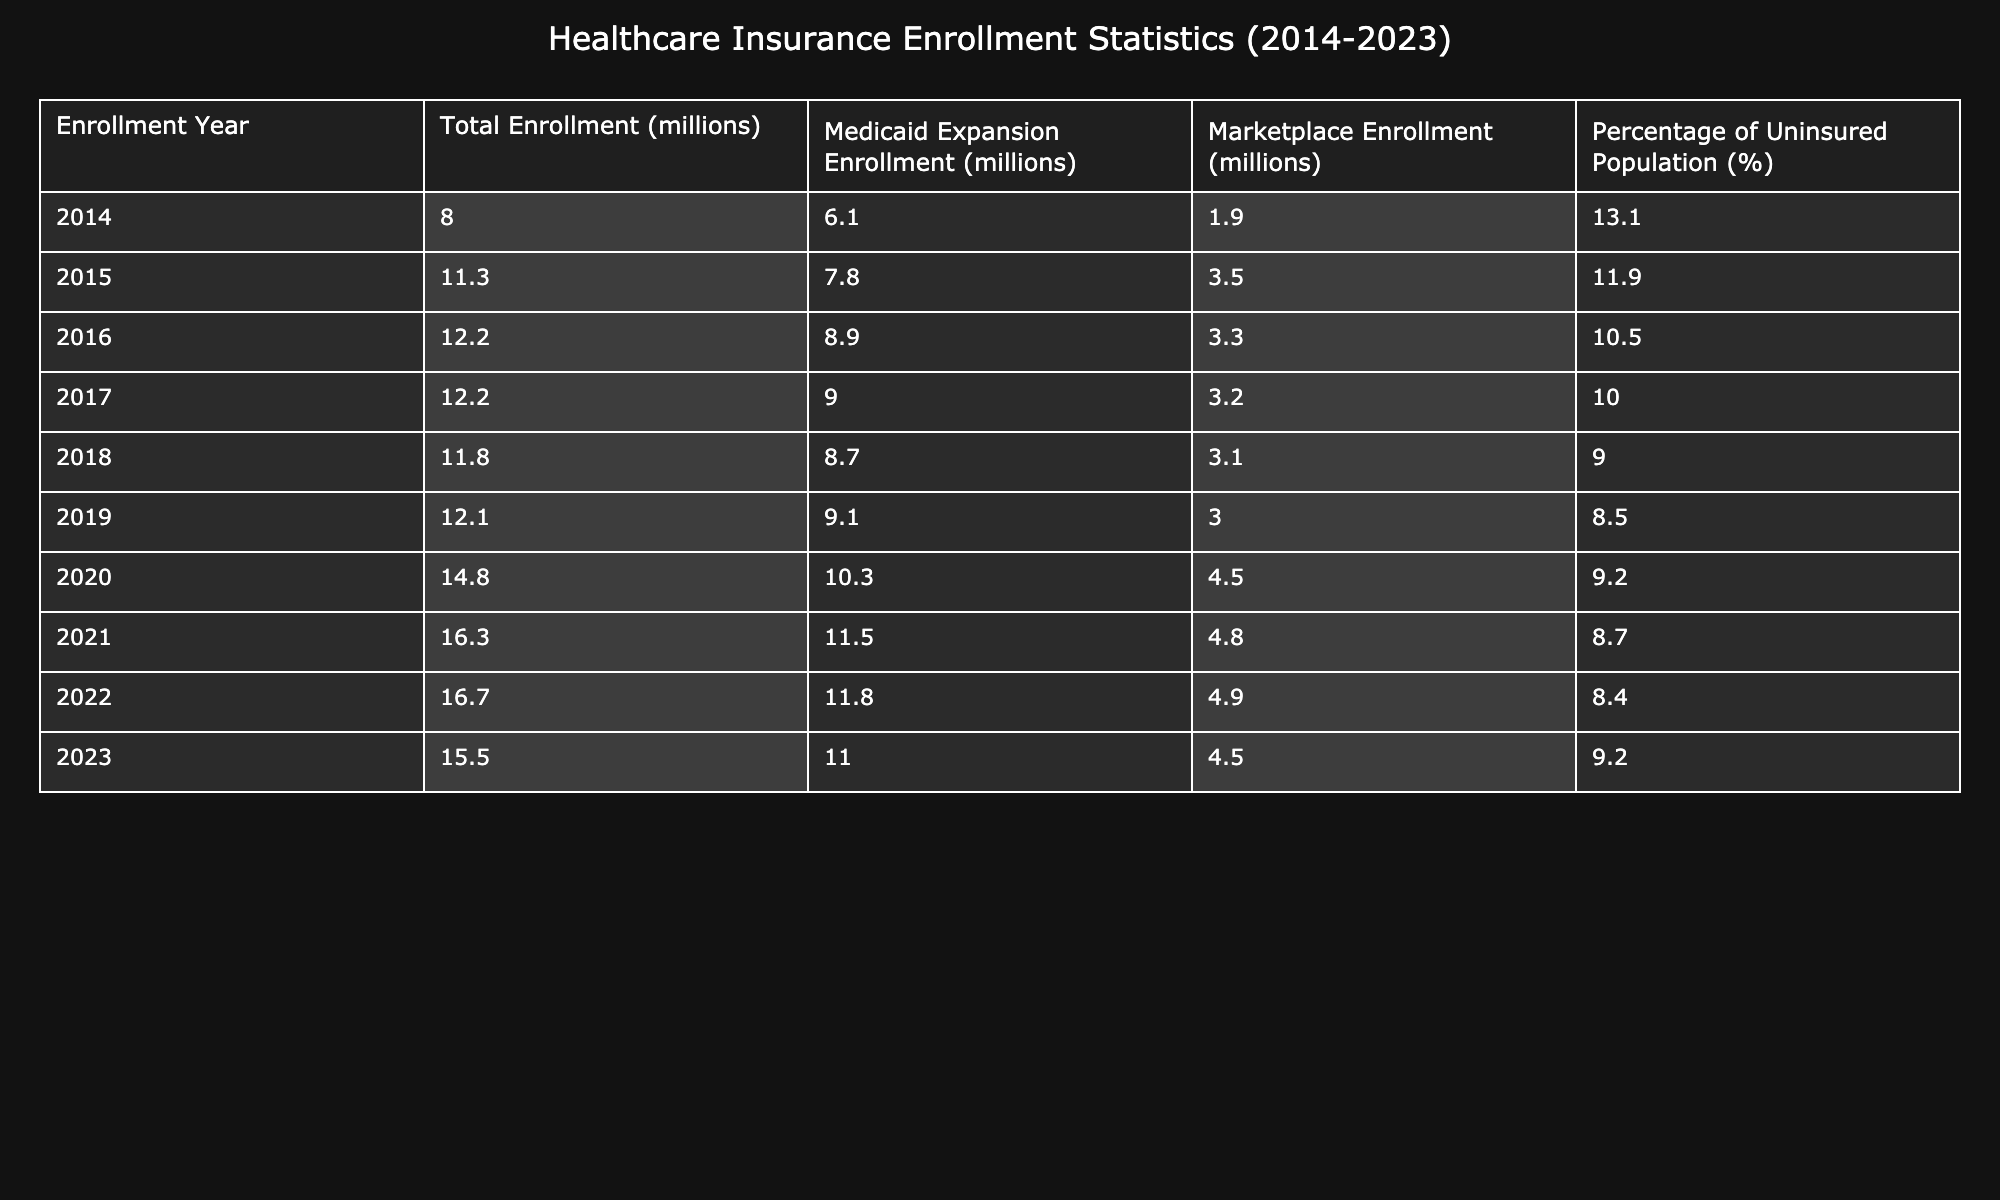What's the total enrollment in 2020? For the year 2020, the "Total Enrollment" value is directly referenced in the table, which shows it as 14.8 million.
Answer: 14.8 million What percentage of the uninsured population was there in 2015? By checking the "Percentage of Uninsured Population" column for the year 2015, the value is noted as 11.9%.
Answer: 11.9% How many millions enrolled in the Medicaid expansion in 2018? The "Medicaid Expansion Enrollment" for the year 2018 is clearly stated in the table as 8.7 million.
Answer: 8.7 million Which year had the highest marketplace enrollment? Looking at the "Marketplace Enrollment" column, the highest value is 4.8 million, which occurs in the year 2021.
Answer: 2021 What is the average percentage of the uninsured population from 2014 to 2023? Adding the percentages from each year: 13.1 + 11.9 + 10.5 + 10.0 + 9.0 + 8.5 + 9.2 + 8.7 + 8.4 + 9.2 gives a total of 88.5%. Dividing by the 10 years, we have 88.5/10 = 8.85%.
Answer: 8.85% Was there a decrease in the total enrollment from 2022 to 2023? Comparing the total enrollment for 2022 (16.7 million) and for 2023 (15.5 million), there is a decrease of 1.2 million, indicating a decline.
Answer: Yes What was the difference in Medicaid expansion enrollment between 2014 and 2021? The enrollment in Medicaid expansion in 2014 was 6.1 million, and in 2021 it was 11.5 million. The difference is 11.5 - 6.1 = 5.4 million.
Answer: 5.4 million In what year was the total enrollment equal to the Marketplace enrollment? In the years 2016 and 2017, both had total enrollments of 12.2 million, while the Marketplace enrollments during those years were 3.3 and 3.2 million respectively. None of the years have equal figures for both total and marketplace enrollments.
Answer: No year How many more millions enrolled in the marketplace in 2021 compared to 2020? The marketplace enrollment in 2021 was 4.8 million, while in 2020 it was 4.5 million. The difference is 4.8 - 4.5 = 0.3 million.
Answer: 0.3 million What trend is observed in the percentage of the uninsured population from 2014 to 2023? By closely looking at the table, the uninsured percentage decreases from 13.1% in 2014 to 8.4% in 2022, but it rises again to 9.2% in 2023. This indicates a generally declining trend, with an uptick in the last year.
Answer: Decreasing overall, slight uptick in 2023 